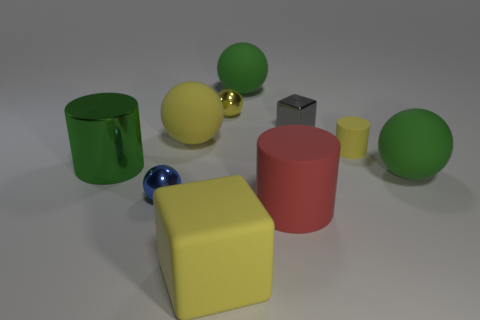Do the large green cylinder and the big green sphere to the left of the small yellow cylinder have the same material?
Ensure brevity in your answer.  No. The big matte cube has what color?
Provide a short and direct response. Yellow. What is the shape of the large yellow object in front of the red rubber cylinder?
Your answer should be compact. Cube. What number of red things are either big spheres or spheres?
Your answer should be compact. 0. What is the color of the small cylinder that is the same material as the large block?
Offer a terse response. Yellow. There is a big matte cylinder; is its color the same as the cylinder behind the large green cylinder?
Ensure brevity in your answer.  No. What is the color of the matte object that is both in front of the yellow rubber cylinder and to the right of the small cube?
Your response must be concise. Green. There is a large cube; what number of blue spheres are in front of it?
Your response must be concise. 0. What number of things are either green metallic cylinders or balls behind the green shiny object?
Offer a terse response. 4. There is a tiny sphere that is to the left of the large matte cube; is there a small object on the left side of it?
Ensure brevity in your answer.  No. 